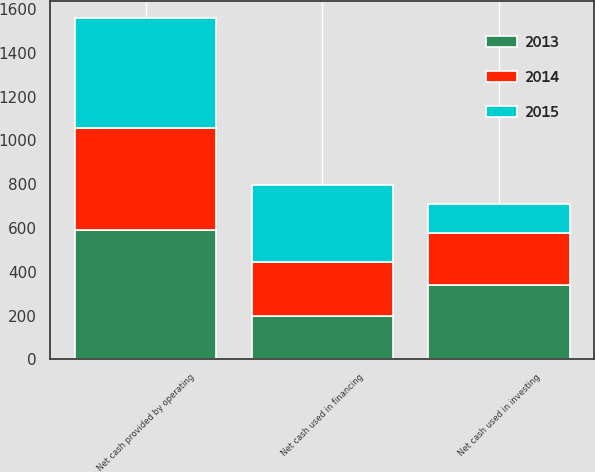Convert chart to OTSL. <chart><loc_0><loc_0><loc_500><loc_500><stacked_bar_chart><ecel><fcel>Net cash provided by operating<fcel>Net cash used in investing<fcel>Net cash used in financing<nl><fcel>2013<fcel>590<fcel>338.9<fcel>199.6<nl><fcel>2015<fcel>503.6<fcel>131.6<fcel>348.9<nl><fcel>2014<fcel>465.2<fcel>239.7<fcel>245.9<nl></chart> 